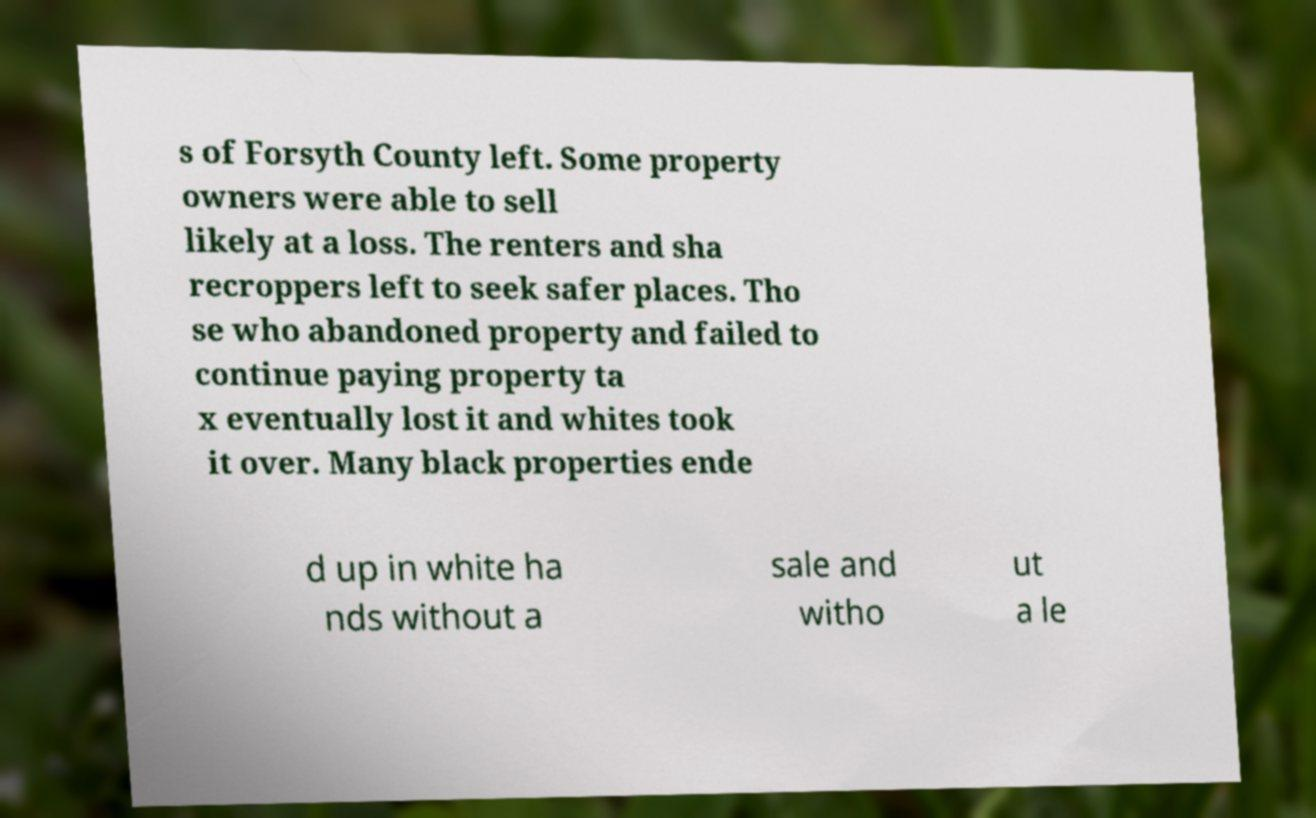Please read and relay the text visible in this image. What does it say? s of Forsyth County left. Some property owners were able to sell likely at a loss. The renters and sha recroppers left to seek safer places. Tho se who abandoned property and failed to continue paying property ta x eventually lost it and whites took it over. Many black properties ende d up in white ha nds without a sale and witho ut a le 